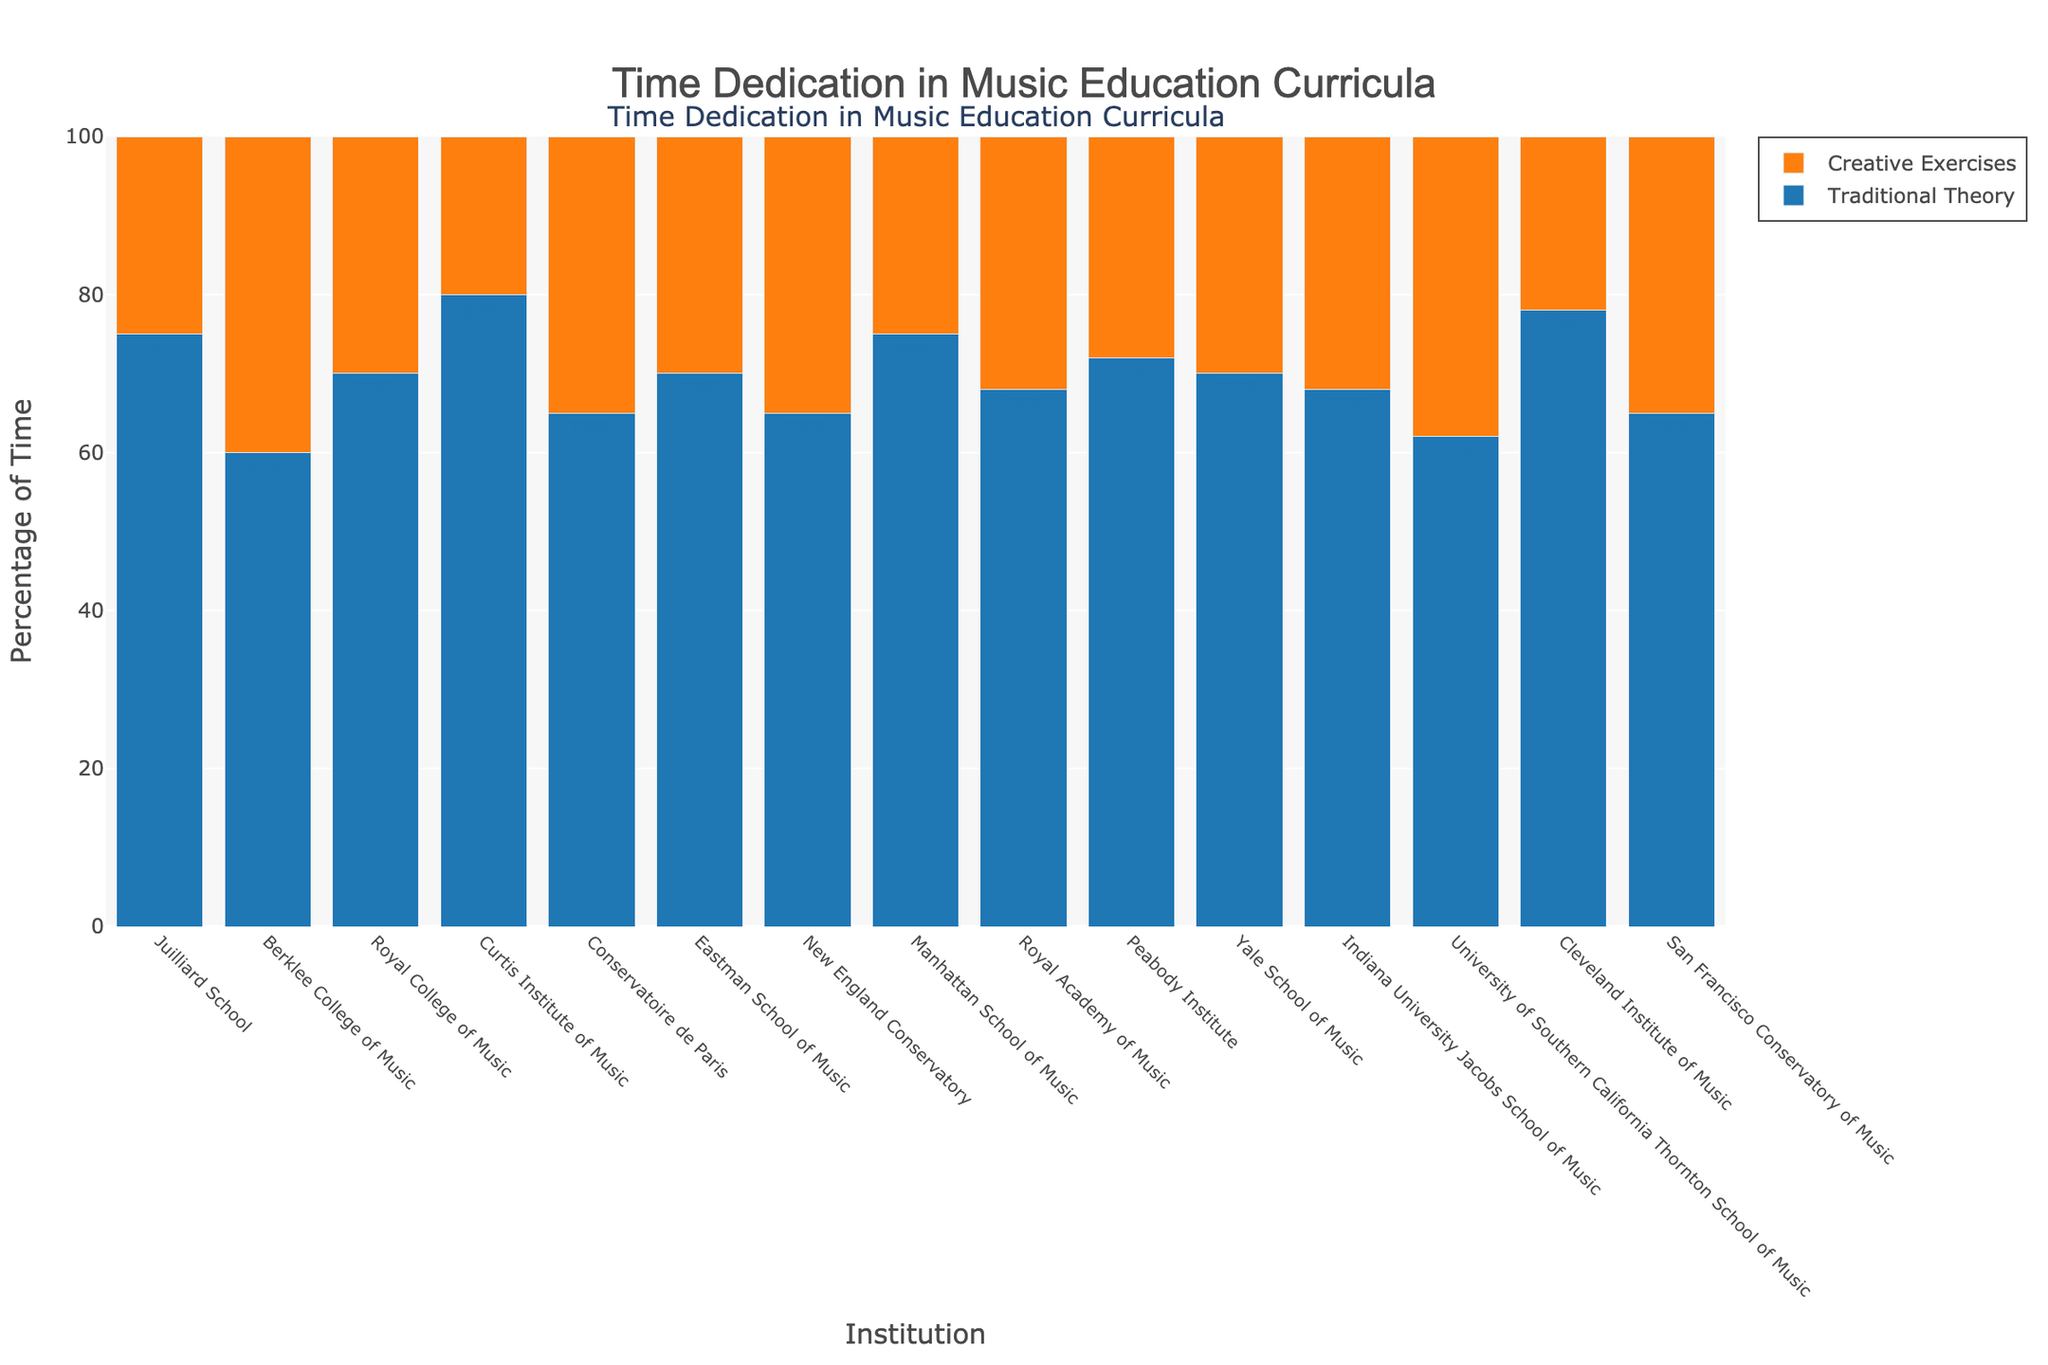What percentage of time is dedicated to creative exercises at Berklee College of Music? Look at the bar representing Berklee College of Music and locate the segment for creative exercises. The height of this segment shows the percentage.
Answer: 40% Which institution allocates the highest percentage of time to traditional theory? Look at the heights of the bars representing traditional theory across all institutions and identify the tallest one.
Answer: Curtis Institute of Music How much more time does the Juilliard School dedicate to traditional theory compared to creative exercises? Identify the percentages for traditional theory and creative exercises at the Juilliard School and calculate the difference: 75% for traditional theory minus 25% for creative exercises.
Answer: 50% What is the average percentage of time dedicated to creative exercises across all institutions? Add up the percentages dedicated to creative exercises for all institutions and divide by the number of institutions: (25% + 40% + 30% + 20% + 35% + 30% + 35% + 25% + 32% + 28% + 30% + 32% + 38% + 22% + 35%) / 15.
Answer: 30.67% Which institution has a more balanced distribution between traditional theory and creative exercises, the Royal College of Music or the Conservatoire de Paris? Compare the differences between traditional theory and creative exercises for both institutions: Royal College of Music (70% - 30% = 40%) and Conservatoire de Paris (65% - 35% = 30%). The smaller the difference, the more balanced the distribution.
Answer: Conservatoire de Paris Are there any institutions where the percentage of time dedicated to creative exercises is equal to or greater than 35%? If so, which are they? Scan the bars to find segments for creative exercises that are equal to or greater than 35%.
Answer: Berklee College of Music, Conservatoire de Paris, New England Conservatory, University of Southern California Thornton School of Music, San Francisco Conservatory of Music Does the Eastman School of Music dedicate more time to creative exercises than traditional theory? Locate the bar segments for both traditional theory and creative exercises at Eastman School of Music and compare their heights. The traditional theory segment is taller.
Answer: No What is the sum of the percentages dedicated to traditional theory for Juilliard School and Manhattan School of Music? Add the percentages dedicated to traditional theory for both institutions: 75% (Juilliard School) + 75% (Manhattan School of Music).
Answer: 150% Which institution allocates a larger portion of time to creative exercises, Yale School of Music or Indiana University Jacobs School of Music? Compare the height of the creative exercises segments for both institutions: 30% (Yale School of Music) and 32% (Indiana University Jacobs School of Music).
Answer: Indiana University Jacobs School of Music 